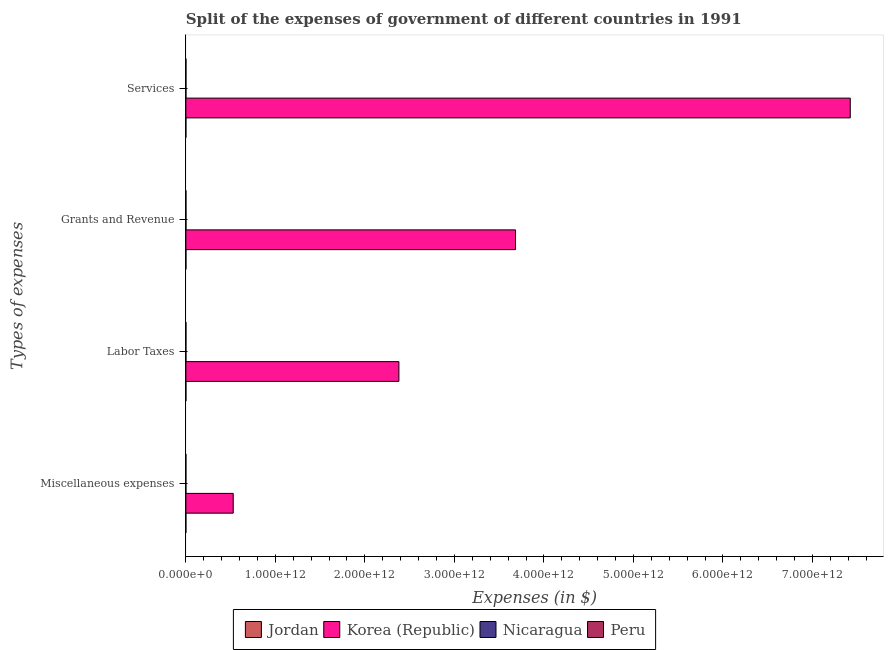How many bars are there on the 1st tick from the bottom?
Give a very brief answer. 4. What is the label of the 2nd group of bars from the top?
Provide a short and direct response. Grants and Revenue. What is the amount spent on services in Nicaragua?
Your answer should be compact. 5.63e+08. Across all countries, what is the maximum amount spent on miscellaneous expenses?
Offer a terse response. 5.29e+11. Across all countries, what is the minimum amount spent on miscellaneous expenses?
Your answer should be compact. 5.00e+06. In which country was the amount spent on labor taxes maximum?
Your answer should be compact. Korea (Republic). In which country was the amount spent on services minimum?
Your response must be concise. Jordan. What is the total amount spent on labor taxes in the graph?
Offer a very short reply. 2.38e+12. What is the difference between the amount spent on services in Peru and that in Korea (Republic)?
Offer a terse response. -7.42e+12. What is the difference between the amount spent on labor taxes in Nicaragua and the amount spent on grants and revenue in Jordan?
Keep it short and to the point. -3.43e+08. What is the average amount spent on services per country?
Provide a succinct answer. 1.86e+12. What is the difference between the amount spent on labor taxes and amount spent on grants and revenue in Korea (Republic)?
Ensure brevity in your answer.  -1.30e+12. What is the ratio of the amount spent on grants and revenue in Peru to that in Nicaragua?
Give a very brief answer. 0.28. What is the difference between the highest and the second highest amount spent on miscellaneous expenses?
Keep it short and to the point. 5.29e+11. What is the difference between the highest and the lowest amount spent on miscellaneous expenses?
Provide a succinct answer. 5.29e+11. Is it the case that in every country, the sum of the amount spent on miscellaneous expenses and amount spent on labor taxes is greater than the sum of amount spent on grants and revenue and amount spent on services?
Offer a very short reply. No. What does the 2nd bar from the bottom in Labor Taxes represents?
Offer a very short reply. Korea (Republic). How many bars are there?
Provide a short and direct response. 16. How many countries are there in the graph?
Your answer should be very brief. 4. What is the difference between two consecutive major ticks on the X-axis?
Offer a terse response. 1.00e+12. Are the values on the major ticks of X-axis written in scientific E-notation?
Your answer should be very brief. Yes. Does the graph contain any zero values?
Make the answer very short. No. How many legend labels are there?
Offer a very short reply. 4. What is the title of the graph?
Offer a terse response. Split of the expenses of government of different countries in 1991. Does "Somalia" appear as one of the legend labels in the graph?
Your answer should be compact. No. What is the label or title of the X-axis?
Your response must be concise. Expenses (in $). What is the label or title of the Y-axis?
Provide a short and direct response. Types of expenses. What is the Expenses (in $) in Jordan in Miscellaneous expenses?
Your answer should be very brief. 1.57e+07. What is the Expenses (in $) of Korea (Republic) in Miscellaneous expenses?
Keep it short and to the point. 5.29e+11. What is the Expenses (in $) of Nicaragua in Miscellaneous expenses?
Make the answer very short. 1.75e+07. What is the Expenses (in $) of Peru in Miscellaneous expenses?
Your answer should be very brief. 5.00e+06. What is the Expenses (in $) in Jordan in Labor Taxes?
Give a very brief answer. 7.18e+07. What is the Expenses (in $) of Korea (Republic) in Labor Taxes?
Offer a terse response. 2.38e+12. What is the Expenses (in $) in Nicaragua in Labor Taxes?
Your answer should be very brief. 1.17e+08. What is the Expenses (in $) of Peru in Labor Taxes?
Provide a short and direct response. 4.48e+08. What is the Expenses (in $) of Jordan in Grants and Revenue?
Your answer should be very brief. 4.59e+08. What is the Expenses (in $) of Korea (Republic) in Grants and Revenue?
Make the answer very short. 3.68e+12. What is the Expenses (in $) in Nicaragua in Grants and Revenue?
Make the answer very short. 9.76e+08. What is the Expenses (in $) of Peru in Grants and Revenue?
Your answer should be very brief. 2.74e+08. What is the Expenses (in $) of Jordan in Services?
Make the answer very short. 4.94e+07. What is the Expenses (in $) in Korea (Republic) in Services?
Your answer should be compact. 7.42e+12. What is the Expenses (in $) in Nicaragua in Services?
Your answer should be compact. 5.63e+08. What is the Expenses (in $) of Peru in Services?
Offer a very short reply. 5.97e+08. Across all Types of expenses, what is the maximum Expenses (in $) of Jordan?
Provide a short and direct response. 4.59e+08. Across all Types of expenses, what is the maximum Expenses (in $) in Korea (Republic)?
Your answer should be very brief. 7.42e+12. Across all Types of expenses, what is the maximum Expenses (in $) in Nicaragua?
Your answer should be compact. 9.76e+08. Across all Types of expenses, what is the maximum Expenses (in $) in Peru?
Provide a succinct answer. 5.97e+08. Across all Types of expenses, what is the minimum Expenses (in $) in Jordan?
Offer a very short reply. 1.57e+07. Across all Types of expenses, what is the minimum Expenses (in $) of Korea (Republic)?
Provide a succinct answer. 5.29e+11. Across all Types of expenses, what is the minimum Expenses (in $) of Nicaragua?
Make the answer very short. 1.75e+07. What is the total Expenses (in $) in Jordan in the graph?
Give a very brief answer. 5.96e+08. What is the total Expenses (in $) in Korea (Republic) in the graph?
Provide a succinct answer. 1.40e+13. What is the total Expenses (in $) in Nicaragua in the graph?
Keep it short and to the point. 1.67e+09. What is the total Expenses (in $) in Peru in the graph?
Your answer should be compact. 1.32e+09. What is the difference between the Expenses (in $) in Jordan in Miscellaneous expenses and that in Labor Taxes?
Give a very brief answer. -5.62e+07. What is the difference between the Expenses (in $) of Korea (Republic) in Miscellaneous expenses and that in Labor Taxes?
Keep it short and to the point. -1.85e+12. What is the difference between the Expenses (in $) of Nicaragua in Miscellaneous expenses and that in Labor Taxes?
Your answer should be very brief. -9.91e+07. What is the difference between the Expenses (in $) of Peru in Miscellaneous expenses and that in Labor Taxes?
Make the answer very short. -4.43e+08. What is the difference between the Expenses (in $) of Jordan in Miscellaneous expenses and that in Grants and Revenue?
Ensure brevity in your answer.  -4.44e+08. What is the difference between the Expenses (in $) in Korea (Republic) in Miscellaneous expenses and that in Grants and Revenue?
Your response must be concise. -3.15e+12. What is the difference between the Expenses (in $) in Nicaragua in Miscellaneous expenses and that in Grants and Revenue?
Provide a short and direct response. -9.58e+08. What is the difference between the Expenses (in $) in Peru in Miscellaneous expenses and that in Grants and Revenue?
Your answer should be compact. -2.69e+08. What is the difference between the Expenses (in $) of Jordan in Miscellaneous expenses and that in Services?
Provide a succinct answer. -3.38e+07. What is the difference between the Expenses (in $) in Korea (Republic) in Miscellaneous expenses and that in Services?
Keep it short and to the point. -6.89e+12. What is the difference between the Expenses (in $) of Nicaragua in Miscellaneous expenses and that in Services?
Provide a short and direct response. -5.46e+08. What is the difference between the Expenses (in $) in Peru in Miscellaneous expenses and that in Services?
Ensure brevity in your answer.  -5.92e+08. What is the difference between the Expenses (in $) in Jordan in Labor Taxes and that in Grants and Revenue?
Offer a very short reply. -3.88e+08. What is the difference between the Expenses (in $) in Korea (Republic) in Labor Taxes and that in Grants and Revenue?
Your answer should be very brief. -1.30e+12. What is the difference between the Expenses (in $) of Nicaragua in Labor Taxes and that in Grants and Revenue?
Offer a terse response. -8.59e+08. What is the difference between the Expenses (in $) of Peru in Labor Taxes and that in Grants and Revenue?
Your answer should be very brief. 1.74e+08. What is the difference between the Expenses (in $) of Jordan in Labor Taxes and that in Services?
Your answer should be very brief. 2.24e+07. What is the difference between the Expenses (in $) of Korea (Republic) in Labor Taxes and that in Services?
Your response must be concise. -5.04e+12. What is the difference between the Expenses (in $) of Nicaragua in Labor Taxes and that in Services?
Your answer should be compact. -4.47e+08. What is the difference between the Expenses (in $) of Peru in Labor Taxes and that in Services?
Offer a terse response. -1.49e+08. What is the difference between the Expenses (in $) in Jordan in Grants and Revenue and that in Services?
Offer a very short reply. 4.10e+08. What is the difference between the Expenses (in $) of Korea (Republic) in Grants and Revenue and that in Services?
Give a very brief answer. -3.74e+12. What is the difference between the Expenses (in $) in Nicaragua in Grants and Revenue and that in Services?
Offer a very short reply. 4.12e+08. What is the difference between the Expenses (in $) in Peru in Grants and Revenue and that in Services?
Ensure brevity in your answer.  -3.23e+08. What is the difference between the Expenses (in $) of Jordan in Miscellaneous expenses and the Expenses (in $) of Korea (Republic) in Labor Taxes?
Make the answer very short. -2.38e+12. What is the difference between the Expenses (in $) in Jordan in Miscellaneous expenses and the Expenses (in $) in Nicaragua in Labor Taxes?
Your answer should be very brief. -1.01e+08. What is the difference between the Expenses (in $) of Jordan in Miscellaneous expenses and the Expenses (in $) of Peru in Labor Taxes?
Offer a terse response. -4.32e+08. What is the difference between the Expenses (in $) in Korea (Republic) in Miscellaneous expenses and the Expenses (in $) in Nicaragua in Labor Taxes?
Keep it short and to the point. 5.29e+11. What is the difference between the Expenses (in $) of Korea (Republic) in Miscellaneous expenses and the Expenses (in $) of Peru in Labor Taxes?
Your response must be concise. 5.29e+11. What is the difference between the Expenses (in $) in Nicaragua in Miscellaneous expenses and the Expenses (in $) in Peru in Labor Taxes?
Keep it short and to the point. -4.30e+08. What is the difference between the Expenses (in $) in Jordan in Miscellaneous expenses and the Expenses (in $) in Korea (Republic) in Grants and Revenue?
Keep it short and to the point. -3.68e+12. What is the difference between the Expenses (in $) in Jordan in Miscellaneous expenses and the Expenses (in $) in Nicaragua in Grants and Revenue?
Your answer should be compact. -9.60e+08. What is the difference between the Expenses (in $) of Jordan in Miscellaneous expenses and the Expenses (in $) of Peru in Grants and Revenue?
Offer a terse response. -2.58e+08. What is the difference between the Expenses (in $) of Korea (Republic) in Miscellaneous expenses and the Expenses (in $) of Nicaragua in Grants and Revenue?
Provide a succinct answer. 5.28e+11. What is the difference between the Expenses (in $) of Korea (Republic) in Miscellaneous expenses and the Expenses (in $) of Peru in Grants and Revenue?
Provide a short and direct response. 5.29e+11. What is the difference between the Expenses (in $) in Nicaragua in Miscellaneous expenses and the Expenses (in $) in Peru in Grants and Revenue?
Provide a short and direct response. -2.56e+08. What is the difference between the Expenses (in $) in Jordan in Miscellaneous expenses and the Expenses (in $) in Korea (Republic) in Services?
Give a very brief answer. -7.42e+12. What is the difference between the Expenses (in $) in Jordan in Miscellaneous expenses and the Expenses (in $) in Nicaragua in Services?
Your response must be concise. -5.48e+08. What is the difference between the Expenses (in $) in Jordan in Miscellaneous expenses and the Expenses (in $) in Peru in Services?
Make the answer very short. -5.81e+08. What is the difference between the Expenses (in $) in Korea (Republic) in Miscellaneous expenses and the Expenses (in $) in Nicaragua in Services?
Provide a succinct answer. 5.28e+11. What is the difference between the Expenses (in $) in Korea (Republic) in Miscellaneous expenses and the Expenses (in $) in Peru in Services?
Give a very brief answer. 5.28e+11. What is the difference between the Expenses (in $) of Nicaragua in Miscellaneous expenses and the Expenses (in $) of Peru in Services?
Offer a very short reply. -5.79e+08. What is the difference between the Expenses (in $) in Jordan in Labor Taxes and the Expenses (in $) in Korea (Republic) in Grants and Revenue?
Make the answer very short. -3.68e+12. What is the difference between the Expenses (in $) in Jordan in Labor Taxes and the Expenses (in $) in Nicaragua in Grants and Revenue?
Your response must be concise. -9.04e+08. What is the difference between the Expenses (in $) in Jordan in Labor Taxes and the Expenses (in $) in Peru in Grants and Revenue?
Offer a very short reply. -2.02e+08. What is the difference between the Expenses (in $) in Korea (Republic) in Labor Taxes and the Expenses (in $) in Nicaragua in Grants and Revenue?
Ensure brevity in your answer.  2.38e+12. What is the difference between the Expenses (in $) in Korea (Republic) in Labor Taxes and the Expenses (in $) in Peru in Grants and Revenue?
Your response must be concise. 2.38e+12. What is the difference between the Expenses (in $) in Nicaragua in Labor Taxes and the Expenses (in $) in Peru in Grants and Revenue?
Offer a very short reply. -1.57e+08. What is the difference between the Expenses (in $) in Jordan in Labor Taxes and the Expenses (in $) in Korea (Republic) in Services?
Ensure brevity in your answer.  -7.42e+12. What is the difference between the Expenses (in $) of Jordan in Labor Taxes and the Expenses (in $) of Nicaragua in Services?
Make the answer very short. -4.92e+08. What is the difference between the Expenses (in $) in Jordan in Labor Taxes and the Expenses (in $) in Peru in Services?
Provide a succinct answer. -5.25e+08. What is the difference between the Expenses (in $) of Korea (Republic) in Labor Taxes and the Expenses (in $) of Nicaragua in Services?
Provide a short and direct response. 2.38e+12. What is the difference between the Expenses (in $) of Korea (Republic) in Labor Taxes and the Expenses (in $) of Peru in Services?
Ensure brevity in your answer.  2.38e+12. What is the difference between the Expenses (in $) of Nicaragua in Labor Taxes and the Expenses (in $) of Peru in Services?
Offer a terse response. -4.80e+08. What is the difference between the Expenses (in $) of Jordan in Grants and Revenue and the Expenses (in $) of Korea (Republic) in Services?
Make the answer very short. -7.42e+12. What is the difference between the Expenses (in $) in Jordan in Grants and Revenue and the Expenses (in $) in Nicaragua in Services?
Your answer should be compact. -1.04e+08. What is the difference between the Expenses (in $) of Jordan in Grants and Revenue and the Expenses (in $) of Peru in Services?
Provide a short and direct response. -1.38e+08. What is the difference between the Expenses (in $) of Korea (Republic) in Grants and Revenue and the Expenses (in $) of Nicaragua in Services?
Your answer should be very brief. 3.68e+12. What is the difference between the Expenses (in $) of Korea (Republic) in Grants and Revenue and the Expenses (in $) of Peru in Services?
Keep it short and to the point. 3.68e+12. What is the difference between the Expenses (in $) of Nicaragua in Grants and Revenue and the Expenses (in $) of Peru in Services?
Offer a terse response. 3.79e+08. What is the average Expenses (in $) of Jordan per Types of expenses?
Your answer should be very brief. 1.49e+08. What is the average Expenses (in $) of Korea (Republic) per Types of expenses?
Keep it short and to the point. 3.50e+12. What is the average Expenses (in $) in Nicaragua per Types of expenses?
Offer a very short reply. 4.18e+08. What is the average Expenses (in $) of Peru per Types of expenses?
Provide a succinct answer. 3.31e+08. What is the difference between the Expenses (in $) in Jordan and Expenses (in $) in Korea (Republic) in Miscellaneous expenses?
Offer a very short reply. -5.29e+11. What is the difference between the Expenses (in $) of Jordan and Expenses (in $) of Nicaragua in Miscellaneous expenses?
Provide a succinct answer. -1.86e+06. What is the difference between the Expenses (in $) of Jordan and Expenses (in $) of Peru in Miscellaneous expenses?
Offer a very short reply. 1.07e+07. What is the difference between the Expenses (in $) in Korea (Republic) and Expenses (in $) in Nicaragua in Miscellaneous expenses?
Your answer should be compact. 5.29e+11. What is the difference between the Expenses (in $) of Korea (Republic) and Expenses (in $) of Peru in Miscellaneous expenses?
Your response must be concise. 5.29e+11. What is the difference between the Expenses (in $) in Nicaragua and Expenses (in $) in Peru in Miscellaneous expenses?
Your answer should be compact. 1.25e+07. What is the difference between the Expenses (in $) in Jordan and Expenses (in $) in Korea (Republic) in Labor Taxes?
Provide a succinct answer. -2.38e+12. What is the difference between the Expenses (in $) in Jordan and Expenses (in $) in Nicaragua in Labor Taxes?
Ensure brevity in your answer.  -4.47e+07. What is the difference between the Expenses (in $) of Jordan and Expenses (in $) of Peru in Labor Taxes?
Ensure brevity in your answer.  -3.76e+08. What is the difference between the Expenses (in $) of Korea (Republic) and Expenses (in $) of Nicaragua in Labor Taxes?
Your response must be concise. 2.38e+12. What is the difference between the Expenses (in $) in Korea (Republic) and Expenses (in $) in Peru in Labor Taxes?
Your answer should be very brief. 2.38e+12. What is the difference between the Expenses (in $) in Nicaragua and Expenses (in $) in Peru in Labor Taxes?
Offer a terse response. -3.31e+08. What is the difference between the Expenses (in $) in Jordan and Expenses (in $) in Korea (Republic) in Grants and Revenue?
Keep it short and to the point. -3.68e+12. What is the difference between the Expenses (in $) of Jordan and Expenses (in $) of Nicaragua in Grants and Revenue?
Ensure brevity in your answer.  -5.16e+08. What is the difference between the Expenses (in $) in Jordan and Expenses (in $) in Peru in Grants and Revenue?
Your answer should be compact. 1.85e+08. What is the difference between the Expenses (in $) in Korea (Republic) and Expenses (in $) in Nicaragua in Grants and Revenue?
Ensure brevity in your answer.  3.68e+12. What is the difference between the Expenses (in $) of Korea (Republic) and Expenses (in $) of Peru in Grants and Revenue?
Make the answer very short. 3.68e+12. What is the difference between the Expenses (in $) in Nicaragua and Expenses (in $) in Peru in Grants and Revenue?
Offer a very short reply. 7.02e+08. What is the difference between the Expenses (in $) of Jordan and Expenses (in $) of Korea (Republic) in Services?
Provide a succinct answer. -7.42e+12. What is the difference between the Expenses (in $) in Jordan and Expenses (in $) in Nicaragua in Services?
Give a very brief answer. -5.14e+08. What is the difference between the Expenses (in $) in Jordan and Expenses (in $) in Peru in Services?
Your answer should be compact. -5.48e+08. What is the difference between the Expenses (in $) of Korea (Republic) and Expenses (in $) of Nicaragua in Services?
Your response must be concise. 7.42e+12. What is the difference between the Expenses (in $) in Korea (Republic) and Expenses (in $) in Peru in Services?
Offer a very short reply. 7.42e+12. What is the difference between the Expenses (in $) in Nicaragua and Expenses (in $) in Peru in Services?
Provide a short and direct response. -3.36e+07. What is the ratio of the Expenses (in $) in Jordan in Miscellaneous expenses to that in Labor Taxes?
Ensure brevity in your answer.  0.22. What is the ratio of the Expenses (in $) of Korea (Republic) in Miscellaneous expenses to that in Labor Taxes?
Your response must be concise. 0.22. What is the ratio of the Expenses (in $) in Nicaragua in Miscellaneous expenses to that in Labor Taxes?
Make the answer very short. 0.15. What is the ratio of the Expenses (in $) of Peru in Miscellaneous expenses to that in Labor Taxes?
Offer a terse response. 0.01. What is the ratio of the Expenses (in $) of Jordan in Miscellaneous expenses to that in Grants and Revenue?
Your response must be concise. 0.03. What is the ratio of the Expenses (in $) of Korea (Republic) in Miscellaneous expenses to that in Grants and Revenue?
Provide a short and direct response. 0.14. What is the ratio of the Expenses (in $) in Nicaragua in Miscellaneous expenses to that in Grants and Revenue?
Offer a terse response. 0.02. What is the ratio of the Expenses (in $) of Peru in Miscellaneous expenses to that in Grants and Revenue?
Provide a short and direct response. 0.02. What is the ratio of the Expenses (in $) of Jordan in Miscellaneous expenses to that in Services?
Offer a terse response. 0.32. What is the ratio of the Expenses (in $) in Korea (Republic) in Miscellaneous expenses to that in Services?
Offer a very short reply. 0.07. What is the ratio of the Expenses (in $) in Nicaragua in Miscellaneous expenses to that in Services?
Ensure brevity in your answer.  0.03. What is the ratio of the Expenses (in $) in Peru in Miscellaneous expenses to that in Services?
Make the answer very short. 0.01. What is the ratio of the Expenses (in $) in Jordan in Labor Taxes to that in Grants and Revenue?
Offer a very short reply. 0.16. What is the ratio of the Expenses (in $) in Korea (Republic) in Labor Taxes to that in Grants and Revenue?
Keep it short and to the point. 0.65. What is the ratio of the Expenses (in $) of Nicaragua in Labor Taxes to that in Grants and Revenue?
Your response must be concise. 0.12. What is the ratio of the Expenses (in $) in Peru in Labor Taxes to that in Grants and Revenue?
Offer a very short reply. 1.63. What is the ratio of the Expenses (in $) in Jordan in Labor Taxes to that in Services?
Your response must be concise. 1.45. What is the ratio of the Expenses (in $) of Korea (Republic) in Labor Taxes to that in Services?
Give a very brief answer. 0.32. What is the ratio of the Expenses (in $) of Nicaragua in Labor Taxes to that in Services?
Offer a terse response. 0.21. What is the ratio of the Expenses (in $) of Jordan in Grants and Revenue to that in Services?
Make the answer very short. 9.3. What is the ratio of the Expenses (in $) of Korea (Republic) in Grants and Revenue to that in Services?
Give a very brief answer. 0.5. What is the ratio of the Expenses (in $) in Nicaragua in Grants and Revenue to that in Services?
Provide a short and direct response. 1.73. What is the ratio of the Expenses (in $) in Peru in Grants and Revenue to that in Services?
Your answer should be compact. 0.46. What is the difference between the highest and the second highest Expenses (in $) in Jordan?
Offer a terse response. 3.88e+08. What is the difference between the highest and the second highest Expenses (in $) of Korea (Republic)?
Give a very brief answer. 3.74e+12. What is the difference between the highest and the second highest Expenses (in $) in Nicaragua?
Your answer should be compact. 4.12e+08. What is the difference between the highest and the second highest Expenses (in $) of Peru?
Your answer should be compact. 1.49e+08. What is the difference between the highest and the lowest Expenses (in $) of Jordan?
Give a very brief answer. 4.44e+08. What is the difference between the highest and the lowest Expenses (in $) of Korea (Republic)?
Ensure brevity in your answer.  6.89e+12. What is the difference between the highest and the lowest Expenses (in $) of Nicaragua?
Your answer should be compact. 9.58e+08. What is the difference between the highest and the lowest Expenses (in $) of Peru?
Your response must be concise. 5.92e+08. 